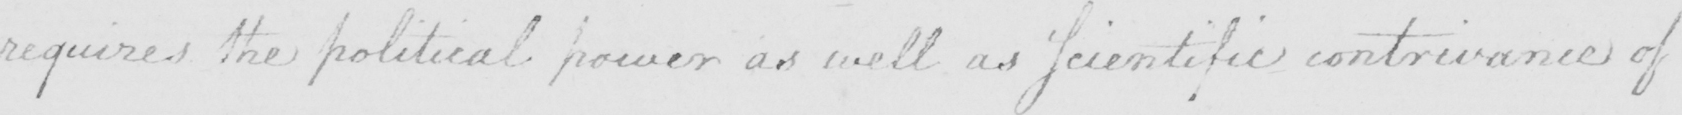Please transcribe the handwritten text in this image. requires the political power as well as Scientific contrivance of 